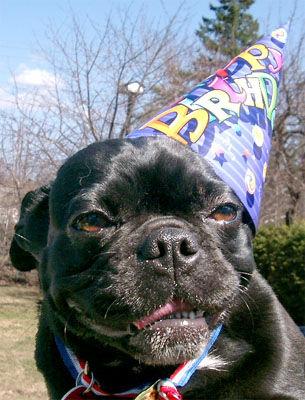What event is this dog celebrating?
Quick response, please. Birthday. What color is the dog?
Write a very short answer. Black. Is the dog wearing a collar?
Short answer required. Yes. 